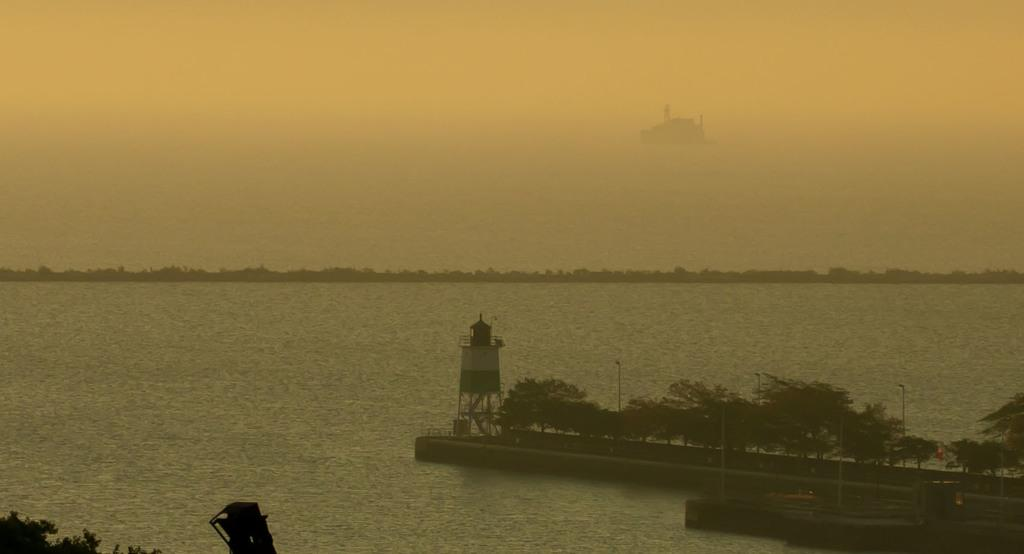What is the primary element visible in the image? There is water in the image. What type of structure can be seen in the image? There is a tower in the image. What type of vegetation is present in the image? There are trees in the image. What are the poles used for in the image? The purpose of the poles in the image is not specified, but they could be used for various purposes such as support or signage. What type of punishment is being carried out in the image? There is no indication of any punishment being carried out in the image. Can you see a rifle in the image? There is no rifle present in the image. 